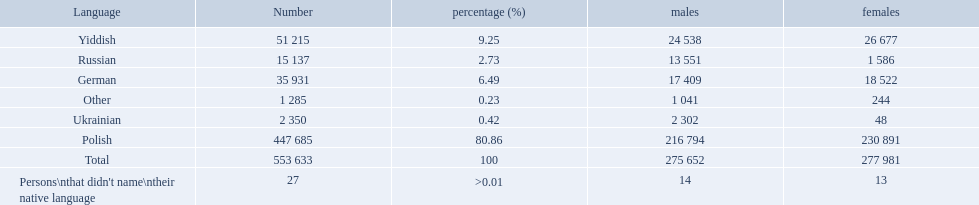What was the least spoken language Ukrainian. What was the most spoken? Polish. 